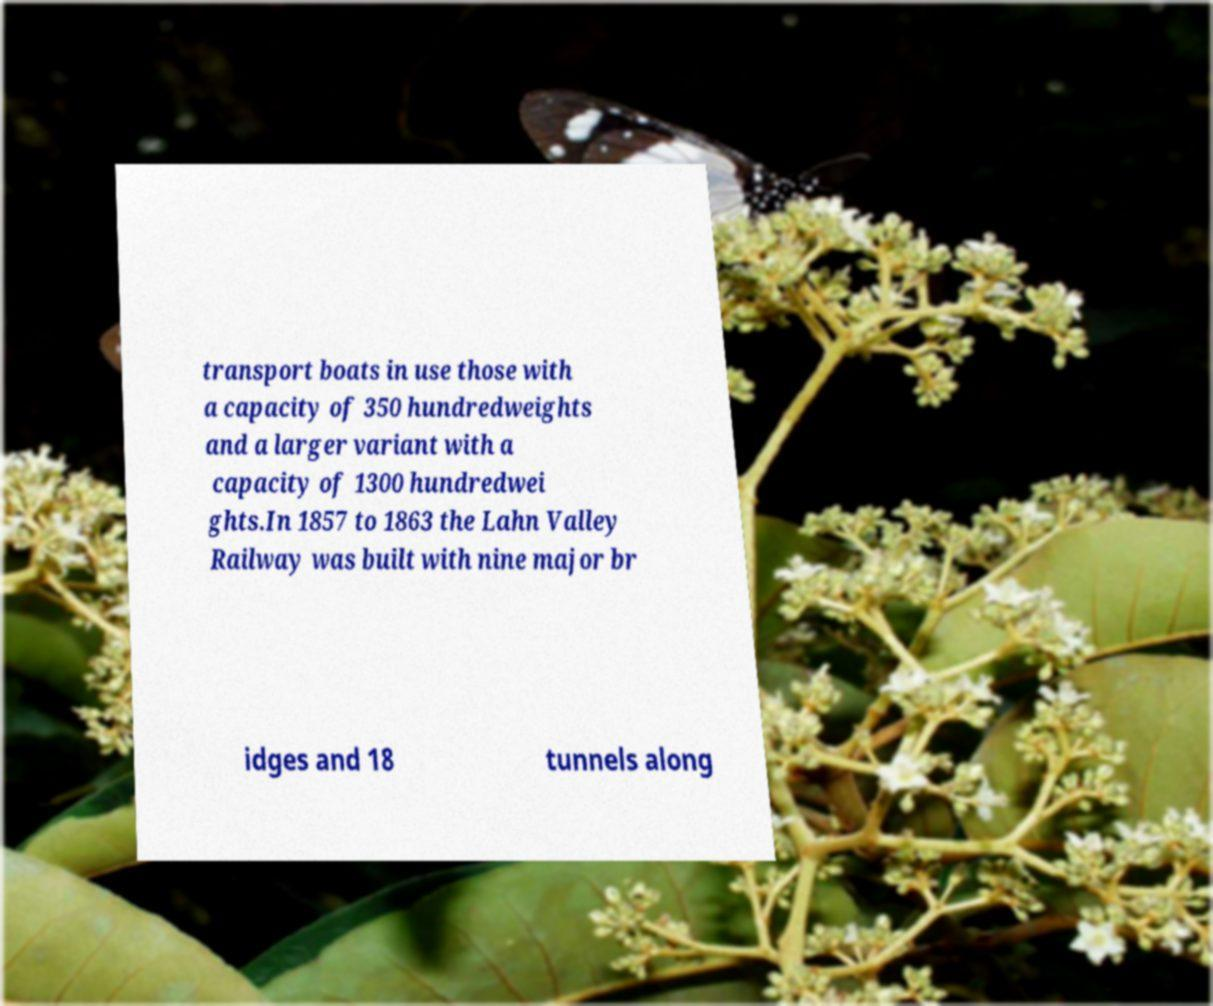There's text embedded in this image that I need extracted. Can you transcribe it verbatim? transport boats in use those with a capacity of 350 hundredweights and a larger variant with a capacity of 1300 hundredwei ghts.In 1857 to 1863 the Lahn Valley Railway was built with nine major br idges and 18 tunnels along 